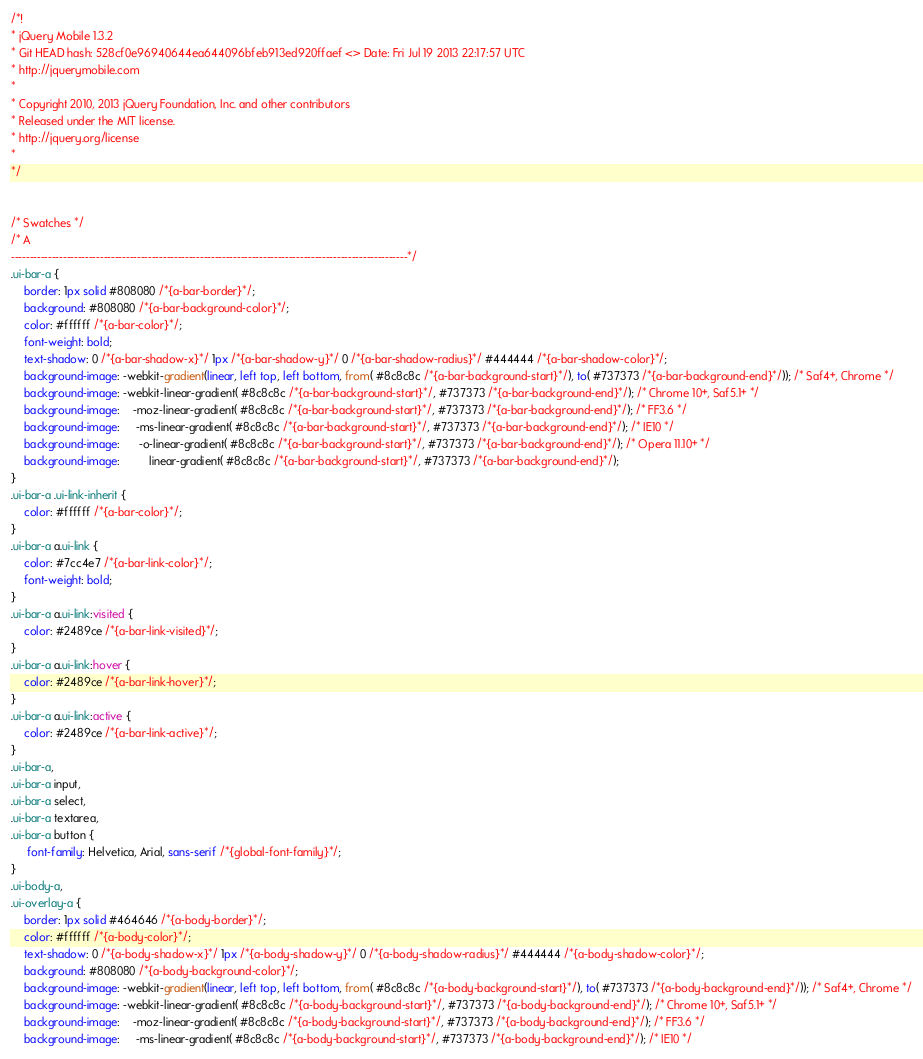Convert code to text. <code><loc_0><loc_0><loc_500><loc_500><_CSS_>/*!
* jQuery Mobile 1.3.2
* Git HEAD hash: 528cf0e96940644ea644096bfeb913ed920ffaef <> Date: Fri Jul 19 2013 22:17:57 UTC
* http://jquerymobile.com
*
* Copyright 2010, 2013 jQuery Foundation, Inc. and other contributors
* Released under the MIT license.
* http://jquery.org/license
*
*/


/* Swatches */
/* A
-----------------------------------------------------------------------------------------------------------*/
.ui-bar-a {
	border: 1px solid #808080 /*{a-bar-border}*/;
	background: #808080 /*{a-bar-background-color}*/;
	color: #ffffff /*{a-bar-color}*/;
	font-weight: bold;
	text-shadow: 0 /*{a-bar-shadow-x}*/ 1px /*{a-bar-shadow-y}*/ 0 /*{a-bar-shadow-radius}*/ #444444 /*{a-bar-shadow-color}*/;
	background-image: -webkit-gradient(linear, left top, left bottom, from( #8c8c8c /*{a-bar-background-start}*/), to( #737373 /*{a-bar-background-end}*/)); /* Saf4+, Chrome */
	background-image: -webkit-linear-gradient( #8c8c8c /*{a-bar-background-start}*/, #737373 /*{a-bar-background-end}*/); /* Chrome 10+, Saf5.1+ */
	background-image:    -moz-linear-gradient( #8c8c8c /*{a-bar-background-start}*/, #737373 /*{a-bar-background-end}*/); /* FF3.6 */
	background-image:     -ms-linear-gradient( #8c8c8c /*{a-bar-background-start}*/, #737373 /*{a-bar-background-end}*/); /* IE10 */
	background-image:      -o-linear-gradient( #8c8c8c /*{a-bar-background-start}*/, #737373 /*{a-bar-background-end}*/); /* Opera 11.10+ */
	background-image:         linear-gradient( #8c8c8c /*{a-bar-background-start}*/, #737373 /*{a-bar-background-end}*/);
}
.ui-bar-a .ui-link-inherit {
	color: #ffffff /*{a-bar-color}*/;
}
.ui-bar-a a.ui-link {
	color: #7cc4e7 /*{a-bar-link-color}*/;
	font-weight: bold;
}
.ui-bar-a a.ui-link:visited {
    color: #2489ce /*{a-bar-link-visited}*/;
}
.ui-bar-a a.ui-link:hover {
	color: #2489ce /*{a-bar-link-hover}*/;
}
.ui-bar-a a.ui-link:active {
	color: #2489ce /*{a-bar-link-active}*/;
}
.ui-bar-a,
.ui-bar-a input,
.ui-bar-a select,
.ui-bar-a textarea,
.ui-bar-a button {
	 font-family: Helvetica, Arial, sans-serif /*{global-font-family}*/;
}
.ui-body-a,
.ui-overlay-a {
	border: 1px solid #464646 /*{a-body-border}*/;
	color: #ffffff /*{a-body-color}*/;
	text-shadow: 0 /*{a-body-shadow-x}*/ 1px /*{a-body-shadow-y}*/ 0 /*{a-body-shadow-radius}*/ #444444 /*{a-body-shadow-color}*/;
	background: #808080 /*{a-body-background-color}*/;
	background-image: -webkit-gradient(linear, left top, left bottom, from( #8c8c8c /*{a-body-background-start}*/), to( #737373 /*{a-body-background-end}*/)); /* Saf4+, Chrome */
	background-image: -webkit-linear-gradient( #8c8c8c /*{a-body-background-start}*/, #737373 /*{a-body-background-end}*/); /* Chrome 10+, Saf5.1+ */
	background-image:    -moz-linear-gradient( #8c8c8c /*{a-body-background-start}*/, #737373 /*{a-body-background-end}*/); /* FF3.6 */
	background-image:     -ms-linear-gradient( #8c8c8c /*{a-body-background-start}*/, #737373 /*{a-body-background-end}*/); /* IE10 */</code> 